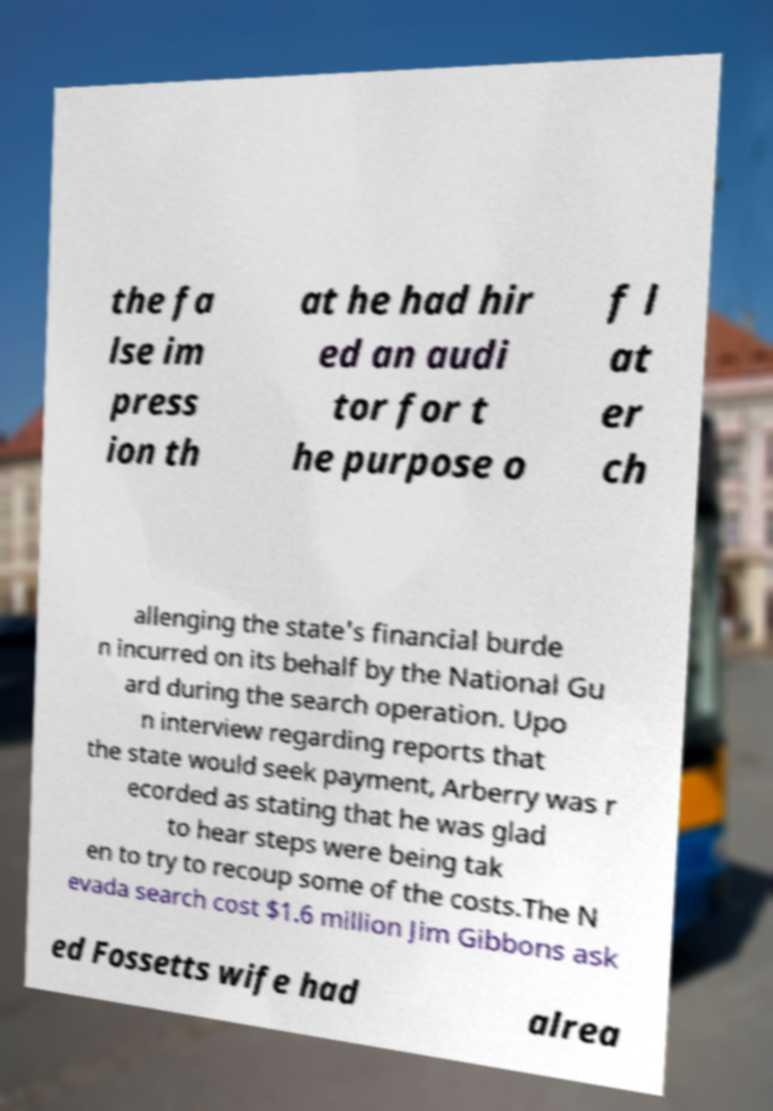I need the written content from this picture converted into text. Can you do that? the fa lse im press ion th at he had hir ed an audi tor for t he purpose o f l at er ch allenging the state's financial burde n incurred on its behalf by the National Gu ard during the search operation. Upo n interview regarding reports that the state would seek payment, Arberry was r ecorded as stating that he was glad to hear steps were being tak en to try to recoup some of the costs.The N evada search cost $1.6 million Jim Gibbons ask ed Fossetts wife had alrea 